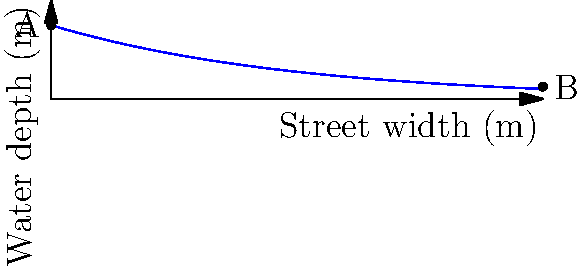As the head of the local disaster response committee, you're analyzing flood water flow through city streets. The graph shows the water depth profile across a 10-meter wide street during a flood. If the Manning's roughness coefficient for the street surface is 0.015 and the street slope is 0.002, what is the approximate flow rate per unit width (in m²/s) at point A? To solve this problem, we'll use Manning's equation for open channel flow:

1) Manning's equation: $Q = \frac{1}{n} A R^{2/3} S^{1/2}$

   Where:
   $Q$ = flow rate (m³/s)
   $n$ = Manning's roughness coefficient
   $A$ = cross-sectional area of flow (m²)
   $R$ = hydraulic radius (m)
   $S$ = slope of the channel

2) For flow rate per unit width (q), we modify the equation:

   $q = \frac{Q}{w} = \frac{1}{n} y^{5/3} S^{1/2}$

   Where:
   $w$ = width of the channel
   $y$ = depth of water

3) Given:
   $n = 0.015$
   $S = 0.002$
   $y = 1.5$ m (at point A)

4) Substituting these values:

   $q = \frac{1}{0.015} (1.5)^{5/3} (0.002)^{1/2}$

5) Calculate:
   $q = 66.67 * 2.76 * 0.0447 = 8.23$ m²/s

Therefore, the approximate flow rate per unit width at point A is 8.23 m²/s.
Answer: 8.23 m²/s 